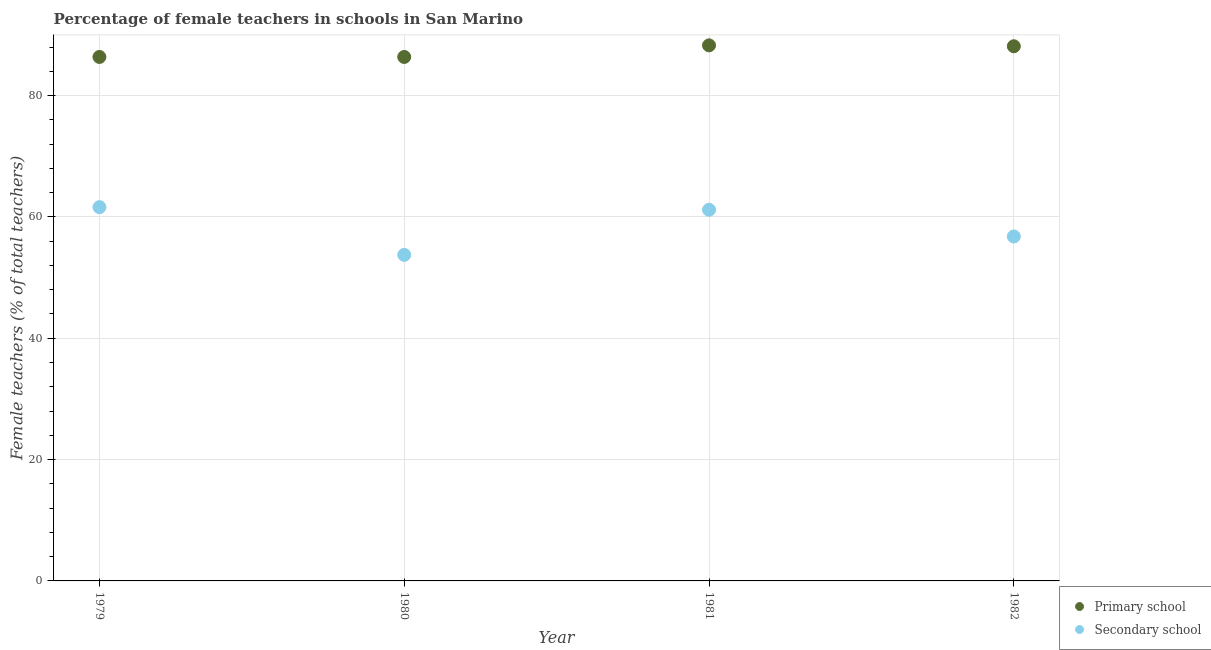How many different coloured dotlines are there?
Ensure brevity in your answer.  2. What is the percentage of female teachers in primary schools in 1980?
Make the answer very short. 86.36. Across all years, what is the maximum percentage of female teachers in primary schools?
Your answer should be very brief. 88.28. Across all years, what is the minimum percentage of female teachers in primary schools?
Ensure brevity in your answer.  86.36. In which year was the percentage of female teachers in primary schools minimum?
Your answer should be very brief. 1979. What is the total percentage of female teachers in primary schools in the graph?
Keep it short and to the point. 349.13. What is the difference between the percentage of female teachers in primary schools in 1981 and that in 1982?
Your response must be concise. 0.15. What is the difference between the percentage of female teachers in secondary schools in 1982 and the percentage of female teachers in primary schools in 1979?
Make the answer very short. -29.59. What is the average percentage of female teachers in secondary schools per year?
Keep it short and to the point. 58.32. In the year 1979, what is the difference between the percentage of female teachers in secondary schools and percentage of female teachers in primary schools?
Keep it short and to the point. -24.76. In how many years, is the percentage of female teachers in primary schools greater than 76 %?
Keep it short and to the point. 4. What is the ratio of the percentage of female teachers in secondary schools in 1979 to that in 1982?
Give a very brief answer. 1.09. Is the percentage of female teachers in primary schools in 1979 less than that in 1981?
Your answer should be very brief. Yes. What is the difference between the highest and the second highest percentage of female teachers in secondary schools?
Provide a succinct answer. 0.43. What is the difference between the highest and the lowest percentage of female teachers in primary schools?
Your answer should be very brief. 1.91. How many years are there in the graph?
Your answer should be very brief. 4. Are the values on the major ticks of Y-axis written in scientific E-notation?
Your answer should be very brief. No. Does the graph contain any zero values?
Your answer should be very brief. No. How many legend labels are there?
Your answer should be very brief. 2. What is the title of the graph?
Your answer should be compact. Percentage of female teachers in schools in San Marino. What is the label or title of the Y-axis?
Offer a very short reply. Female teachers (% of total teachers). What is the Female teachers (% of total teachers) in Primary school in 1979?
Offer a very short reply. 86.36. What is the Female teachers (% of total teachers) of Secondary school in 1979?
Give a very brief answer. 61.61. What is the Female teachers (% of total teachers) of Primary school in 1980?
Your answer should be compact. 86.36. What is the Female teachers (% of total teachers) in Secondary school in 1980?
Provide a short and direct response. 53.74. What is the Female teachers (% of total teachers) in Primary school in 1981?
Provide a short and direct response. 88.28. What is the Female teachers (% of total teachers) of Secondary school in 1981?
Offer a terse response. 61.18. What is the Female teachers (% of total teachers) of Primary school in 1982?
Provide a succinct answer. 88.12. What is the Female teachers (% of total teachers) in Secondary school in 1982?
Make the answer very short. 56.77. Across all years, what is the maximum Female teachers (% of total teachers) of Primary school?
Ensure brevity in your answer.  88.28. Across all years, what is the maximum Female teachers (% of total teachers) in Secondary school?
Your response must be concise. 61.61. Across all years, what is the minimum Female teachers (% of total teachers) in Primary school?
Ensure brevity in your answer.  86.36. Across all years, what is the minimum Female teachers (% of total teachers) of Secondary school?
Your response must be concise. 53.74. What is the total Female teachers (% of total teachers) in Primary school in the graph?
Provide a short and direct response. 349.13. What is the total Female teachers (% of total teachers) in Secondary school in the graph?
Provide a short and direct response. 233.3. What is the difference between the Female teachers (% of total teachers) in Secondary school in 1979 and that in 1980?
Make the answer very short. 7.87. What is the difference between the Female teachers (% of total teachers) in Primary school in 1979 and that in 1981?
Offer a terse response. -1.91. What is the difference between the Female teachers (% of total teachers) of Secondary school in 1979 and that in 1981?
Give a very brief answer. 0.43. What is the difference between the Female teachers (% of total teachers) of Primary school in 1979 and that in 1982?
Your response must be concise. -1.76. What is the difference between the Female teachers (% of total teachers) of Secondary school in 1979 and that in 1982?
Your answer should be very brief. 4.83. What is the difference between the Female teachers (% of total teachers) in Primary school in 1980 and that in 1981?
Offer a very short reply. -1.91. What is the difference between the Female teachers (% of total teachers) in Secondary school in 1980 and that in 1981?
Make the answer very short. -7.43. What is the difference between the Female teachers (% of total teachers) of Primary school in 1980 and that in 1982?
Make the answer very short. -1.76. What is the difference between the Female teachers (% of total teachers) in Secondary school in 1980 and that in 1982?
Your response must be concise. -3.03. What is the difference between the Female teachers (% of total teachers) of Primary school in 1981 and that in 1982?
Give a very brief answer. 0.15. What is the difference between the Female teachers (% of total teachers) in Secondary school in 1981 and that in 1982?
Keep it short and to the point. 4.4. What is the difference between the Female teachers (% of total teachers) in Primary school in 1979 and the Female teachers (% of total teachers) in Secondary school in 1980?
Make the answer very short. 32.62. What is the difference between the Female teachers (% of total teachers) of Primary school in 1979 and the Female teachers (% of total teachers) of Secondary school in 1981?
Provide a succinct answer. 25.19. What is the difference between the Female teachers (% of total teachers) in Primary school in 1979 and the Female teachers (% of total teachers) in Secondary school in 1982?
Offer a terse response. 29.59. What is the difference between the Female teachers (% of total teachers) of Primary school in 1980 and the Female teachers (% of total teachers) of Secondary school in 1981?
Offer a very short reply. 25.19. What is the difference between the Female teachers (% of total teachers) of Primary school in 1980 and the Female teachers (% of total teachers) of Secondary school in 1982?
Give a very brief answer. 29.59. What is the difference between the Female teachers (% of total teachers) of Primary school in 1981 and the Female teachers (% of total teachers) of Secondary school in 1982?
Your answer should be compact. 31.5. What is the average Female teachers (% of total teachers) of Primary school per year?
Offer a terse response. 87.28. What is the average Female teachers (% of total teachers) in Secondary school per year?
Provide a short and direct response. 58.32. In the year 1979, what is the difference between the Female teachers (% of total teachers) of Primary school and Female teachers (% of total teachers) of Secondary school?
Your answer should be compact. 24.76. In the year 1980, what is the difference between the Female teachers (% of total teachers) in Primary school and Female teachers (% of total teachers) in Secondary school?
Keep it short and to the point. 32.62. In the year 1981, what is the difference between the Female teachers (% of total teachers) of Primary school and Female teachers (% of total teachers) of Secondary school?
Give a very brief answer. 27.1. In the year 1982, what is the difference between the Female teachers (% of total teachers) of Primary school and Female teachers (% of total teachers) of Secondary school?
Provide a succinct answer. 31.35. What is the ratio of the Female teachers (% of total teachers) in Secondary school in 1979 to that in 1980?
Give a very brief answer. 1.15. What is the ratio of the Female teachers (% of total teachers) of Primary school in 1979 to that in 1981?
Provide a short and direct response. 0.98. What is the ratio of the Female teachers (% of total teachers) of Primary school in 1979 to that in 1982?
Ensure brevity in your answer.  0.98. What is the ratio of the Female teachers (% of total teachers) in Secondary school in 1979 to that in 1982?
Give a very brief answer. 1.09. What is the ratio of the Female teachers (% of total teachers) in Primary school in 1980 to that in 1981?
Offer a terse response. 0.98. What is the ratio of the Female teachers (% of total teachers) in Secondary school in 1980 to that in 1981?
Keep it short and to the point. 0.88. What is the ratio of the Female teachers (% of total teachers) of Primary school in 1980 to that in 1982?
Offer a terse response. 0.98. What is the ratio of the Female teachers (% of total teachers) in Secondary school in 1980 to that in 1982?
Keep it short and to the point. 0.95. What is the ratio of the Female teachers (% of total teachers) in Secondary school in 1981 to that in 1982?
Give a very brief answer. 1.08. What is the difference between the highest and the second highest Female teachers (% of total teachers) in Primary school?
Give a very brief answer. 0.15. What is the difference between the highest and the second highest Female teachers (% of total teachers) of Secondary school?
Make the answer very short. 0.43. What is the difference between the highest and the lowest Female teachers (% of total teachers) of Primary school?
Provide a short and direct response. 1.91. What is the difference between the highest and the lowest Female teachers (% of total teachers) in Secondary school?
Provide a succinct answer. 7.87. 